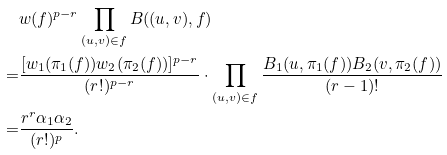<formula> <loc_0><loc_0><loc_500><loc_500>& w ( f ) ^ { p - r } \prod _ { ( u , v ) \in f } B ( ( u , v ) , f ) \\ = & \frac { [ w _ { 1 } ( \pi _ { 1 } ( f ) ) w _ { 2 } ( \pi _ { 2 } ( f ) ) ] ^ { p - r } } { ( r ! ) ^ { p - r } } \cdot \prod _ { ( u , v ) \in f } \frac { B _ { 1 } ( u , \pi _ { 1 } ( f ) ) B _ { 2 } ( v , \pi _ { 2 } ( f ) ) } { ( r - 1 ) ! } \\ = & \frac { r ^ { r } \alpha _ { 1 } \alpha _ { 2 } } { ( r ! ) ^ { p } } .</formula> 